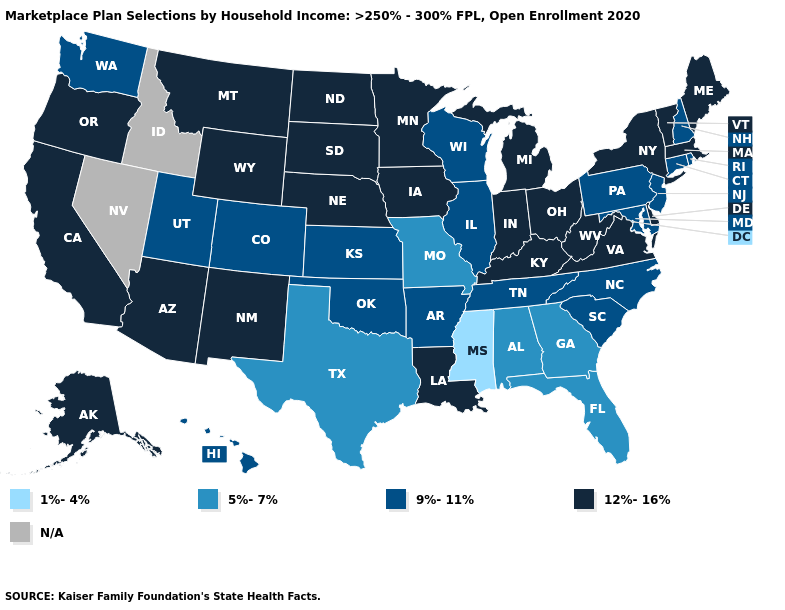Which states have the lowest value in the USA?
Short answer required. Mississippi. Is the legend a continuous bar?
Short answer required. No. Name the states that have a value in the range N/A?
Quick response, please. Idaho, Nevada. Name the states that have a value in the range 5%-7%?
Concise answer only. Alabama, Florida, Georgia, Missouri, Texas. Does Massachusetts have the highest value in the Northeast?
Give a very brief answer. Yes. What is the highest value in states that border Indiana?
Be succinct. 12%-16%. Name the states that have a value in the range 5%-7%?
Give a very brief answer. Alabama, Florida, Georgia, Missouri, Texas. What is the value of New Jersey?
Write a very short answer. 9%-11%. What is the highest value in states that border Ohio?
Keep it brief. 12%-16%. Does New York have the highest value in the Northeast?
Write a very short answer. Yes. Name the states that have a value in the range 12%-16%?
Concise answer only. Alaska, Arizona, California, Delaware, Indiana, Iowa, Kentucky, Louisiana, Maine, Massachusetts, Michigan, Minnesota, Montana, Nebraska, New Mexico, New York, North Dakota, Ohio, Oregon, South Dakota, Vermont, Virginia, West Virginia, Wyoming. What is the value of Pennsylvania?
Be succinct. 9%-11%. Does Mississippi have the lowest value in the USA?
Give a very brief answer. Yes. Which states have the lowest value in the USA?
Be succinct. Mississippi. 